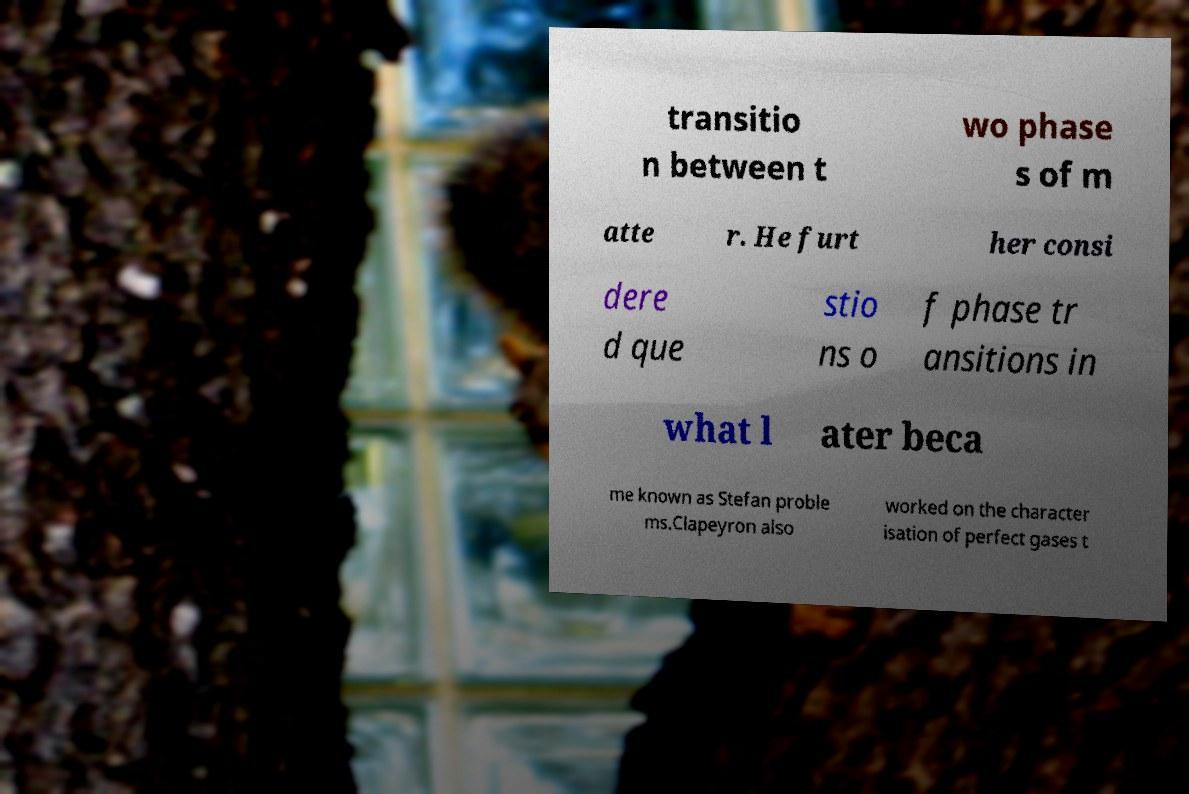There's text embedded in this image that I need extracted. Can you transcribe it verbatim? transitio n between t wo phase s of m atte r. He furt her consi dere d que stio ns o f phase tr ansitions in what l ater beca me known as Stefan proble ms.Clapeyron also worked on the character isation of perfect gases t 